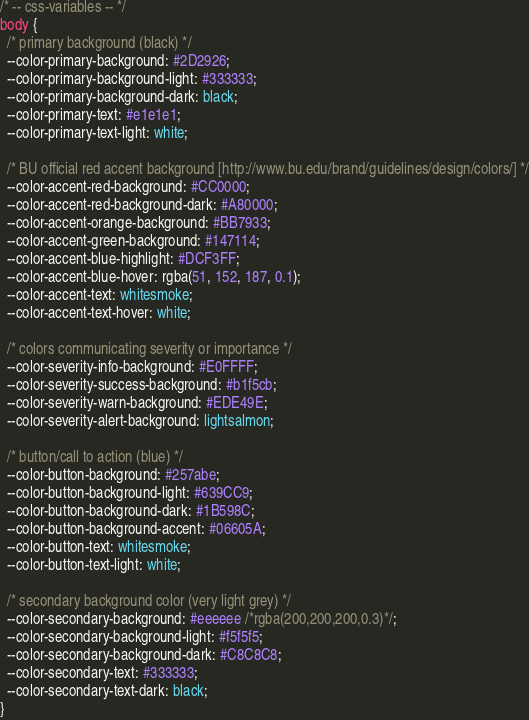Convert code to text. <code><loc_0><loc_0><loc_500><loc_500><_CSS_>/* -- css-variables -- */
body {
  /* primary background (black) */
  --color-primary-background: #2D2926;
  --color-primary-background-light: #333333;
  --color-primary-background-dark: black;
  --color-primary-text: #e1e1e1;
  --color-primary-text-light: white;

  /* BU official red accent background [http://www.bu.edu/brand/guidelines/design/colors/] */
  --color-accent-red-background: #CC0000;
  --color-accent-red-background-dark: #A80000;
  --color-accent-orange-background: #BB7933;
  --color-accent-green-background: #147114;
  --color-accent-blue-highlight: #DCF3FF;
  --color-accent-blue-hover: rgba(51, 152, 187, 0.1); 
  --color-accent-text: whitesmoke;
  --color-accent-text-hover: white;

  /* colors communicating severity or importance */
  --color-severity-info-background: #E0FFFF;
  --color-severity-success-background: #b1f5cb;
  --color-severity-warn-background: #EDE49E;
  --color-severity-alert-background: lightsalmon; 

  /* button/call to action (blue) */
  --color-button-background: #257abe;
  --color-button-background-light: #639CC9;
  --color-button-background-dark: #1B598C;
  --color-button-background-accent: #06605A;
  --color-button-text: whitesmoke;
  --color-button-text-light: white;

  /* secondary background color (very light grey) */
  --color-secondary-background: #eeeeee /*rgba(200,200,200,0.3)*/;
  --color-secondary-background-light: #f5f5f5;
  --color-secondary-background-dark: #C8C8C8;
  --color-secondary-text: #333333;
  --color-secondary-text-dark: black;
}</code> 